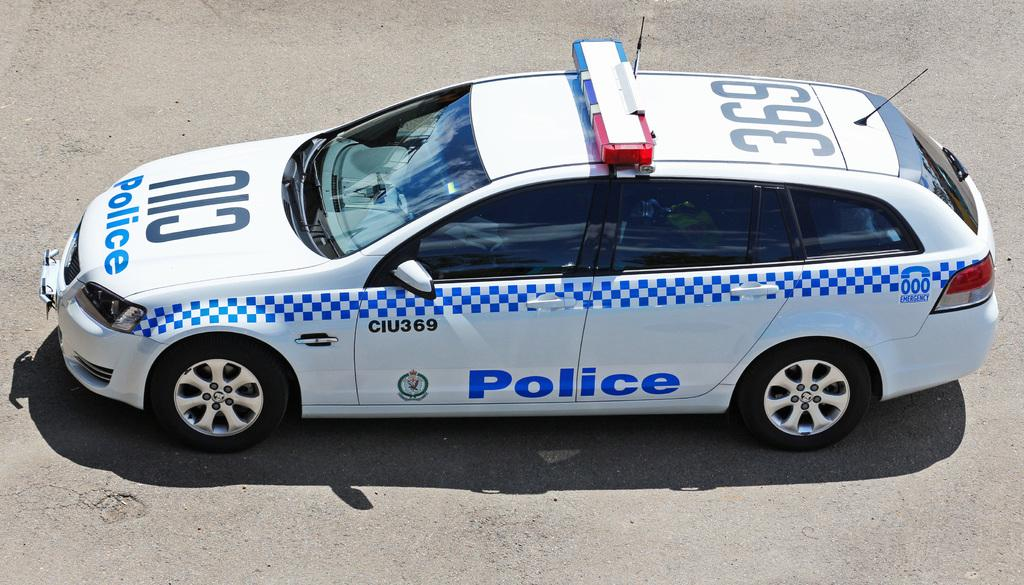What is the main subject of the image? The main subject of the image is a car. What color is the car? The car is white. Where is the car located in the image? The car is on the road. What type of space exploration is depicted in the image? There is no space exploration depicted in the image; it features a white car on the road. What kind of prose can be seen written on the car in the image? There is no prose visible on the car in the image; it is a simple white car on the road. 